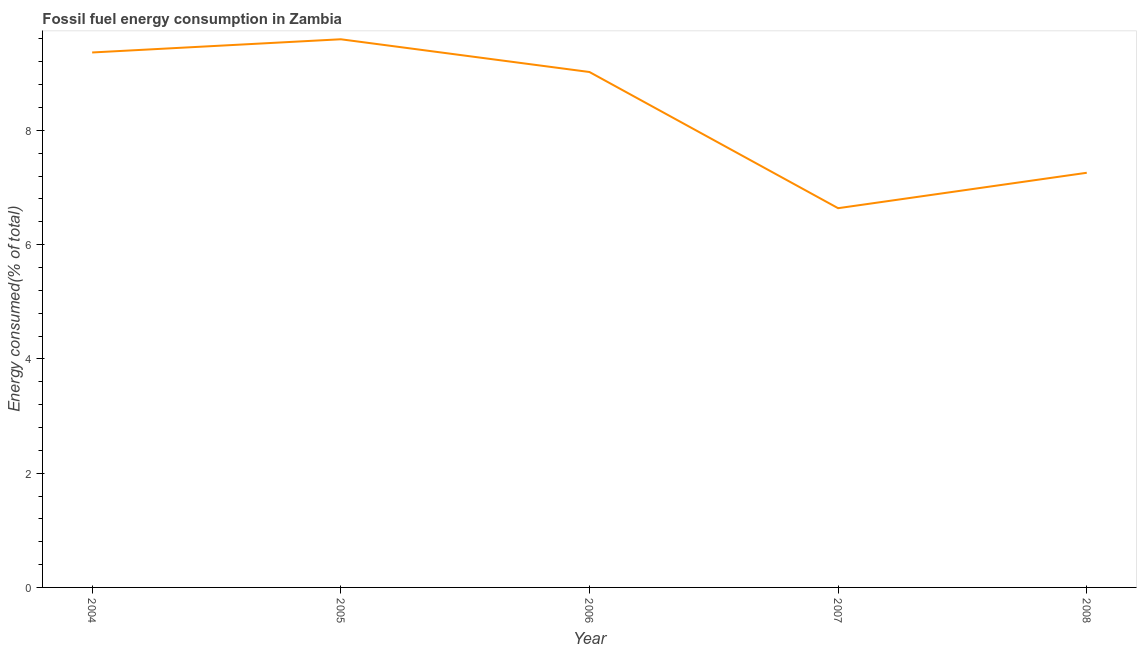What is the fossil fuel energy consumption in 2004?
Offer a very short reply. 9.36. Across all years, what is the maximum fossil fuel energy consumption?
Provide a short and direct response. 9.59. Across all years, what is the minimum fossil fuel energy consumption?
Offer a terse response. 6.64. In which year was the fossil fuel energy consumption maximum?
Offer a terse response. 2005. What is the sum of the fossil fuel energy consumption?
Give a very brief answer. 41.87. What is the difference between the fossil fuel energy consumption in 2004 and 2008?
Your answer should be compact. 2.11. What is the average fossil fuel energy consumption per year?
Keep it short and to the point. 8.37. What is the median fossil fuel energy consumption?
Provide a short and direct response. 9.02. In how many years, is the fossil fuel energy consumption greater than 5.2 %?
Provide a short and direct response. 5. What is the ratio of the fossil fuel energy consumption in 2004 to that in 2005?
Offer a very short reply. 0.98. Is the fossil fuel energy consumption in 2006 less than that in 2008?
Offer a terse response. No. What is the difference between the highest and the second highest fossil fuel energy consumption?
Give a very brief answer. 0.23. What is the difference between the highest and the lowest fossil fuel energy consumption?
Provide a short and direct response. 2.96. In how many years, is the fossil fuel energy consumption greater than the average fossil fuel energy consumption taken over all years?
Your answer should be compact. 3. Does the fossil fuel energy consumption monotonically increase over the years?
Make the answer very short. No. Are the values on the major ticks of Y-axis written in scientific E-notation?
Provide a short and direct response. No. What is the title of the graph?
Your answer should be very brief. Fossil fuel energy consumption in Zambia. What is the label or title of the X-axis?
Give a very brief answer. Year. What is the label or title of the Y-axis?
Your answer should be compact. Energy consumed(% of total). What is the Energy consumed(% of total) of 2004?
Give a very brief answer. 9.36. What is the Energy consumed(% of total) of 2005?
Your response must be concise. 9.59. What is the Energy consumed(% of total) of 2006?
Your response must be concise. 9.02. What is the Energy consumed(% of total) of 2007?
Provide a short and direct response. 6.64. What is the Energy consumed(% of total) of 2008?
Keep it short and to the point. 7.26. What is the difference between the Energy consumed(% of total) in 2004 and 2005?
Offer a very short reply. -0.23. What is the difference between the Energy consumed(% of total) in 2004 and 2006?
Provide a short and direct response. 0.34. What is the difference between the Energy consumed(% of total) in 2004 and 2007?
Keep it short and to the point. 2.73. What is the difference between the Energy consumed(% of total) in 2004 and 2008?
Provide a succinct answer. 2.11. What is the difference between the Energy consumed(% of total) in 2005 and 2006?
Make the answer very short. 0.57. What is the difference between the Energy consumed(% of total) in 2005 and 2007?
Offer a terse response. 2.96. What is the difference between the Energy consumed(% of total) in 2005 and 2008?
Your answer should be compact. 2.34. What is the difference between the Energy consumed(% of total) in 2006 and 2007?
Give a very brief answer. 2.38. What is the difference between the Energy consumed(% of total) in 2006 and 2008?
Offer a terse response. 1.76. What is the difference between the Energy consumed(% of total) in 2007 and 2008?
Provide a succinct answer. -0.62. What is the ratio of the Energy consumed(% of total) in 2004 to that in 2005?
Your response must be concise. 0.98. What is the ratio of the Energy consumed(% of total) in 2004 to that in 2006?
Give a very brief answer. 1.04. What is the ratio of the Energy consumed(% of total) in 2004 to that in 2007?
Keep it short and to the point. 1.41. What is the ratio of the Energy consumed(% of total) in 2004 to that in 2008?
Your answer should be very brief. 1.29. What is the ratio of the Energy consumed(% of total) in 2005 to that in 2006?
Your answer should be compact. 1.06. What is the ratio of the Energy consumed(% of total) in 2005 to that in 2007?
Ensure brevity in your answer.  1.45. What is the ratio of the Energy consumed(% of total) in 2005 to that in 2008?
Your answer should be very brief. 1.32. What is the ratio of the Energy consumed(% of total) in 2006 to that in 2007?
Make the answer very short. 1.36. What is the ratio of the Energy consumed(% of total) in 2006 to that in 2008?
Offer a terse response. 1.24. What is the ratio of the Energy consumed(% of total) in 2007 to that in 2008?
Offer a terse response. 0.92. 